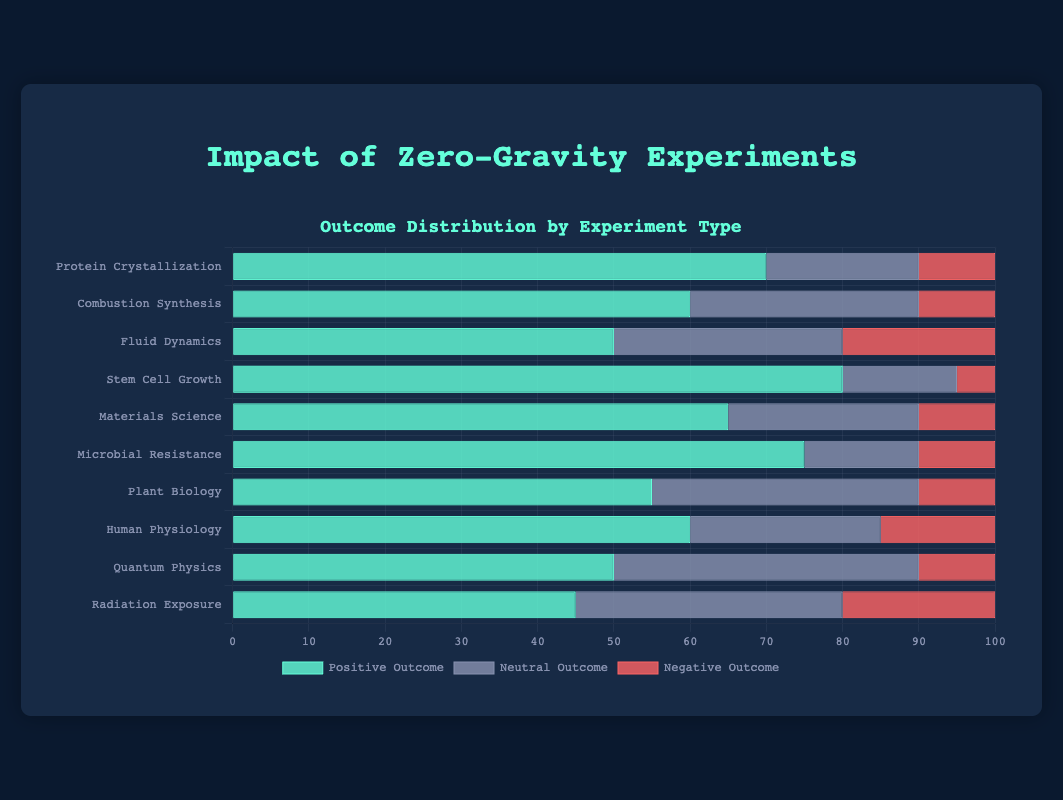Which experiment has the highest positive outcome percentage? The experiment with the highest positive outcome percentage is the one with the greatest value in the "Positive Outcome" bar. According to the chart, "Stem Cell Growth" has the highest positive outcome percentage at 80%.
Answer: Stem Cell Growth Which experiment has the lowest negative outcome percentage? The experiment with the lowest negative outcome percentage is the one with the smallest value in the "Negative Outcome" bar. According to the chart, "Stem Cell Growth" has the lowest negative outcome percentage at 5%.
Answer: Stem Cell Growth What is the combined percentage of negative outcomes for "Fluid Dynamics" and "Radiation Exposure"? To find the combined percentage of negative outcomes for "Fluid Dynamics" and "Radiation Exposure," add their negative outcome percentages: Fluid Dynamics (20%) + Radiation Exposure (20%) = 40%.
Answer: 40% Which experiment has the highest combination of positive and neutral outcomes? To determine this, sum the positive and neutral outcome percentages for each experiment and identify the highest. "Stem Cell Growth" has 80% positive and 15% neutral, totaling 95%. This is the highest combined value.
Answer: Stem Cell Growth Which experiment has the highest neutral outcome percentage? The experiment with the highest neutral outcome percentage is identified by the tallest bar in the "Neutral Outcome" section. "Quantum Physics" has the highest neutral outcome percentage at 40%.
Answer: Quantum Physics Which experiment has a lower positive outcome percentage, "Human Physiology" or "Combustion Synthesis"? Compare the positive outcome percentages for both experiments: Human Physiology (60%) and Combustion Synthesis (60%). Both have equal positive outcome percentages.
Answer: Equal Among all the experiments, what is the average positive outcome percentage? Sum all the positive outcome percentages and divide by the number of experiments. (70 + 60 + 50 + 80 + 65 + 75 + 55 + 60 + 50 + 45) / 10 = 61%.
Answer: 61% What is the total percentage of neutral and negative outcomes combined for "Plant Biology"? Sum the neutral and negative outcome percentages for Plant Biology: 35% neutral + 10% negative = 45%.
Answer: 45% Which experiment has the smallest gap between positive and negative outcomes? Calculate the difference between positive and negative outcome percentages for each experiment. "Quantum Physics" has a gap of 50% (positive) - 10% (negative) = 40%. Comparing all, "Stem Cell Growth" has the smallest gap, which is 80% - 5% = 75%. Each experiment has different steps, ensure to pick the smallest gap.
Answer: Fluid Dynamics, Combustion Synthesis, or Protein Crystallization 